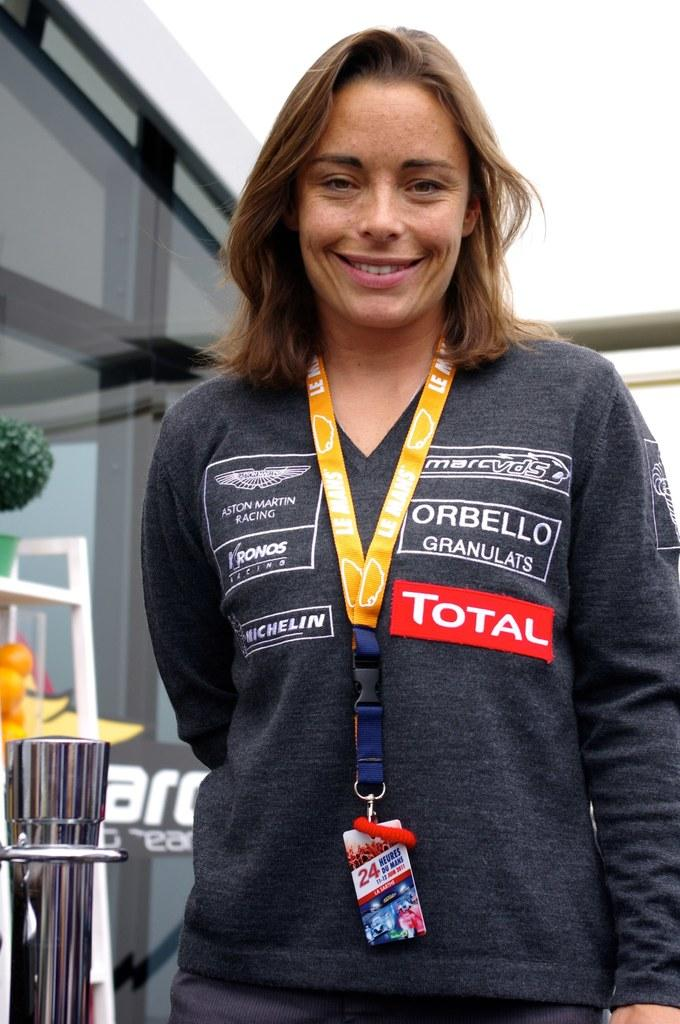<image>
Offer a succinct explanation of the picture presented. A woman has many logos on her shirt, including "total." 